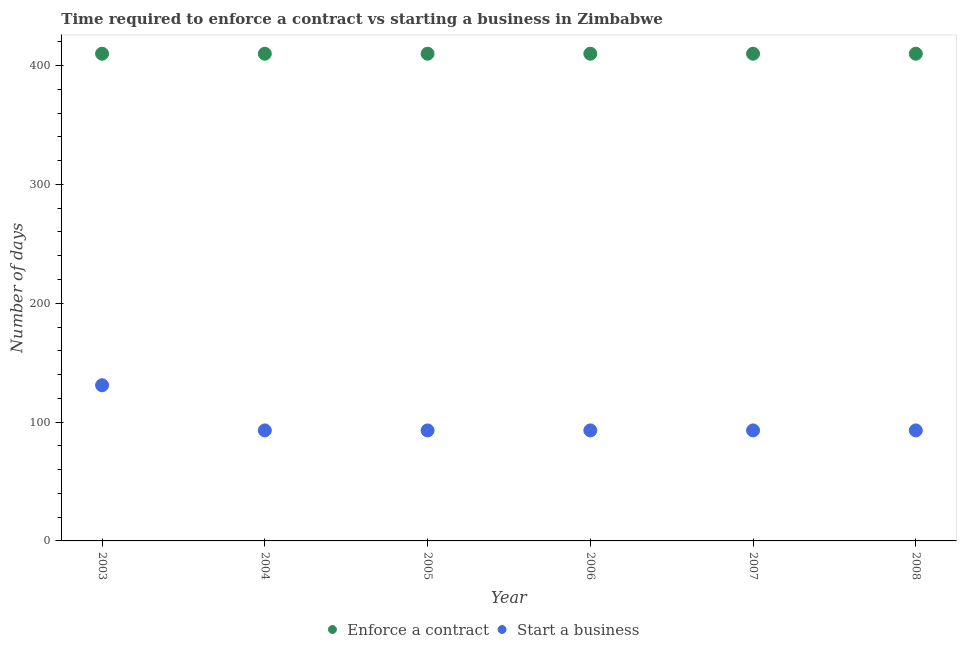How many different coloured dotlines are there?
Offer a very short reply. 2. What is the number of days to start a business in 2003?
Your answer should be compact. 131. Across all years, what is the maximum number of days to enforece a contract?
Your response must be concise. 410. Across all years, what is the minimum number of days to start a business?
Give a very brief answer. 93. In which year was the number of days to start a business maximum?
Your response must be concise. 2003. In which year was the number of days to enforece a contract minimum?
Make the answer very short. 2003. What is the total number of days to enforece a contract in the graph?
Your response must be concise. 2460. What is the difference between the number of days to enforece a contract in 2006 and the number of days to start a business in 2008?
Offer a very short reply. 317. What is the average number of days to start a business per year?
Ensure brevity in your answer.  99.33. In the year 2003, what is the difference between the number of days to enforece a contract and number of days to start a business?
Provide a succinct answer. 279. In how many years, is the number of days to start a business greater than 320 days?
Offer a terse response. 0. What is the ratio of the number of days to start a business in 2003 to that in 2008?
Provide a succinct answer. 1.41. What is the difference between the highest and the second highest number of days to enforece a contract?
Ensure brevity in your answer.  0. In how many years, is the number of days to enforece a contract greater than the average number of days to enforece a contract taken over all years?
Your answer should be very brief. 0. Is the number of days to enforece a contract strictly greater than the number of days to start a business over the years?
Ensure brevity in your answer.  Yes. Is the number of days to enforece a contract strictly less than the number of days to start a business over the years?
Provide a short and direct response. No. How many dotlines are there?
Your answer should be compact. 2. How many years are there in the graph?
Your response must be concise. 6. Are the values on the major ticks of Y-axis written in scientific E-notation?
Your response must be concise. No. Where does the legend appear in the graph?
Make the answer very short. Bottom center. What is the title of the graph?
Provide a succinct answer. Time required to enforce a contract vs starting a business in Zimbabwe. What is the label or title of the Y-axis?
Keep it short and to the point. Number of days. What is the Number of days in Enforce a contract in 2003?
Give a very brief answer. 410. What is the Number of days of Start a business in 2003?
Your response must be concise. 131. What is the Number of days in Enforce a contract in 2004?
Your answer should be very brief. 410. What is the Number of days of Start a business in 2004?
Provide a succinct answer. 93. What is the Number of days in Enforce a contract in 2005?
Ensure brevity in your answer.  410. What is the Number of days in Start a business in 2005?
Your answer should be compact. 93. What is the Number of days of Enforce a contract in 2006?
Your response must be concise. 410. What is the Number of days of Start a business in 2006?
Offer a terse response. 93. What is the Number of days in Enforce a contract in 2007?
Your response must be concise. 410. What is the Number of days in Start a business in 2007?
Provide a succinct answer. 93. What is the Number of days in Enforce a contract in 2008?
Keep it short and to the point. 410. What is the Number of days in Start a business in 2008?
Your answer should be very brief. 93. Across all years, what is the maximum Number of days in Enforce a contract?
Make the answer very short. 410. Across all years, what is the maximum Number of days of Start a business?
Give a very brief answer. 131. Across all years, what is the minimum Number of days in Enforce a contract?
Provide a short and direct response. 410. Across all years, what is the minimum Number of days in Start a business?
Offer a very short reply. 93. What is the total Number of days of Enforce a contract in the graph?
Make the answer very short. 2460. What is the total Number of days in Start a business in the graph?
Offer a very short reply. 596. What is the difference between the Number of days of Start a business in 2003 and that in 2004?
Ensure brevity in your answer.  38. What is the difference between the Number of days in Start a business in 2003 and that in 2005?
Your answer should be very brief. 38. What is the difference between the Number of days of Enforce a contract in 2003 and that in 2006?
Your answer should be compact. 0. What is the difference between the Number of days of Start a business in 2003 and that in 2006?
Give a very brief answer. 38. What is the difference between the Number of days of Start a business in 2003 and that in 2007?
Provide a short and direct response. 38. What is the difference between the Number of days in Enforce a contract in 2004 and that in 2005?
Your response must be concise. 0. What is the difference between the Number of days of Start a business in 2004 and that in 2005?
Your response must be concise. 0. What is the difference between the Number of days of Enforce a contract in 2004 and that in 2006?
Provide a short and direct response. 0. What is the difference between the Number of days of Start a business in 2004 and that in 2006?
Offer a very short reply. 0. What is the difference between the Number of days in Enforce a contract in 2004 and that in 2007?
Offer a very short reply. 0. What is the difference between the Number of days of Start a business in 2004 and that in 2007?
Your answer should be very brief. 0. What is the difference between the Number of days in Enforce a contract in 2005 and that in 2006?
Your answer should be compact. 0. What is the difference between the Number of days of Enforce a contract in 2005 and that in 2007?
Make the answer very short. 0. What is the difference between the Number of days in Enforce a contract in 2005 and that in 2008?
Provide a succinct answer. 0. What is the difference between the Number of days in Enforce a contract in 2006 and that in 2007?
Your answer should be compact. 0. What is the difference between the Number of days in Start a business in 2006 and that in 2007?
Ensure brevity in your answer.  0. What is the difference between the Number of days in Enforce a contract in 2006 and that in 2008?
Ensure brevity in your answer.  0. What is the difference between the Number of days of Enforce a contract in 2007 and that in 2008?
Your answer should be very brief. 0. What is the difference between the Number of days in Start a business in 2007 and that in 2008?
Ensure brevity in your answer.  0. What is the difference between the Number of days in Enforce a contract in 2003 and the Number of days in Start a business in 2004?
Your answer should be compact. 317. What is the difference between the Number of days of Enforce a contract in 2003 and the Number of days of Start a business in 2005?
Offer a terse response. 317. What is the difference between the Number of days of Enforce a contract in 2003 and the Number of days of Start a business in 2006?
Provide a short and direct response. 317. What is the difference between the Number of days of Enforce a contract in 2003 and the Number of days of Start a business in 2007?
Your answer should be compact. 317. What is the difference between the Number of days of Enforce a contract in 2003 and the Number of days of Start a business in 2008?
Ensure brevity in your answer.  317. What is the difference between the Number of days of Enforce a contract in 2004 and the Number of days of Start a business in 2005?
Offer a very short reply. 317. What is the difference between the Number of days in Enforce a contract in 2004 and the Number of days in Start a business in 2006?
Give a very brief answer. 317. What is the difference between the Number of days of Enforce a contract in 2004 and the Number of days of Start a business in 2007?
Provide a short and direct response. 317. What is the difference between the Number of days of Enforce a contract in 2004 and the Number of days of Start a business in 2008?
Your answer should be compact. 317. What is the difference between the Number of days in Enforce a contract in 2005 and the Number of days in Start a business in 2006?
Ensure brevity in your answer.  317. What is the difference between the Number of days of Enforce a contract in 2005 and the Number of days of Start a business in 2007?
Provide a succinct answer. 317. What is the difference between the Number of days in Enforce a contract in 2005 and the Number of days in Start a business in 2008?
Your answer should be compact. 317. What is the difference between the Number of days in Enforce a contract in 2006 and the Number of days in Start a business in 2007?
Your response must be concise. 317. What is the difference between the Number of days in Enforce a contract in 2006 and the Number of days in Start a business in 2008?
Your answer should be compact. 317. What is the difference between the Number of days of Enforce a contract in 2007 and the Number of days of Start a business in 2008?
Your response must be concise. 317. What is the average Number of days in Enforce a contract per year?
Offer a very short reply. 410. What is the average Number of days in Start a business per year?
Your answer should be compact. 99.33. In the year 2003, what is the difference between the Number of days of Enforce a contract and Number of days of Start a business?
Provide a short and direct response. 279. In the year 2004, what is the difference between the Number of days in Enforce a contract and Number of days in Start a business?
Make the answer very short. 317. In the year 2005, what is the difference between the Number of days in Enforce a contract and Number of days in Start a business?
Keep it short and to the point. 317. In the year 2006, what is the difference between the Number of days of Enforce a contract and Number of days of Start a business?
Give a very brief answer. 317. In the year 2007, what is the difference between the Number of days in Enforce a contract and Number of days in Start a business?
Offer a very short reply. 317. In the year 2008, what is the difference between the Number of days of Enforce a contract and Number of days of Start a business?
Provide a short and direct response. 317. What is the ratio of the Number of days in Start a business in 2003 to that in 2004?
Provide a short and direct response. 1.41. What is the ratio of the Number of days in Enforce a contract in 2003 to that in 2005?
Offer a very short reply. 1. What is the ratio of the Number of days in Start a business in 2003 to that in 2005?
Keep it short and to the point. 1.41. What is the ratio of the Number of days of Enforce a contract in 2003 to that in 2006?
Make the answer very short. 1. What is the ratio of the Number of days of Start a business in 2003 to that in 2006?
Provide a short and direct response. 1.41. What is the ratio of the Number of days in Start a business in 2003 to that in 2007?
Your answer should be compact. 1.41. What is the ratio of the Number of days in Start a business in 2003 to that in 2008?
Offer a terse response. 1.41. What is the ratio of the Number of days in Enforce a contract in 2004 to that in 2005?
Your response must be concise. 1. What is the ratio of the Number of days in Enforce a contract in 2004 to that in 2006?
Make the answer very short. 1. What is the ratio of the Number of days of Start a business in 2004 to that in 2006?
Ensure brevity in your answer.  1. What is the ratio of the Number of days in Enforce a contract in 2004 to that in 2007?
Your answer should be compact. 1. What is the ratio of the Number of days of Start a business in 2004 to that in 2007?
Give a very brief answer. 1. What is the ratio of the Number of days of Enforce a contract in 2004 to that in 2008?
Provide a succinct answer. 1. What is the ratio of the Number of days of Start a business in 2005 to that in 2006?
Provide a succinct answer. 1. What is the ratio of the Number of days of Start a business in 2005 to that in 2008?
Keep it short and to the point. 1. What is the ratio of the Number of days of Start a business in 2006 to that in 2007?
Ensure brevity in your answer.  1. What is the ratio of the Number of days in Enforce a contract in 2006 to that in 2008?
Ensure brevity in your answer.  1. What is the ratio of the Number of days of Start a business in 2006 to that in 2008?
Give a very brief answer. 1. What is the difference between the highest and the second highest Number of days of Enforce a contract?
Offer a very short reply. 0. What is the difference between the highest and the lowest Number of days of Enforce a contract?
Offer a terse response. 0. 